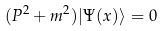<formula> <loc_0><loc_0><loc_500><loc_500>( P ^ { 2 } + m ^ { 2 } ) | \Psi ( x ) \rangle = 0</formula> 